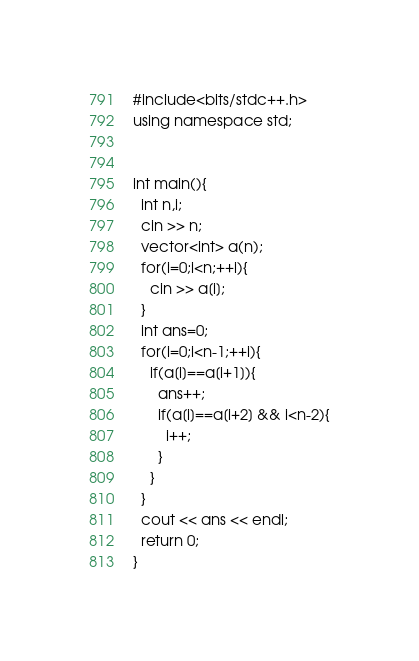Convert code to text. <code><loc_0><loc_0><loc_500><loc_500><_C++_>#include<bits/stdc++.h>
using namespace std;


int main(){
  int n,i;
  cin >> n;
  vector<int> a(n);
  for(i=0;i<n;++i){
    cin >> a[i];
  }
  int ans=0;
  for(i=0;i<n-1;++i){
    if(a[i]==a[i+1]){
      ans++;
      if(a[i]==a[i+2] && i<n-2){
        i++;
      }
    }
  }
  cout << ans << endl;
  return 0;
}
</code> 